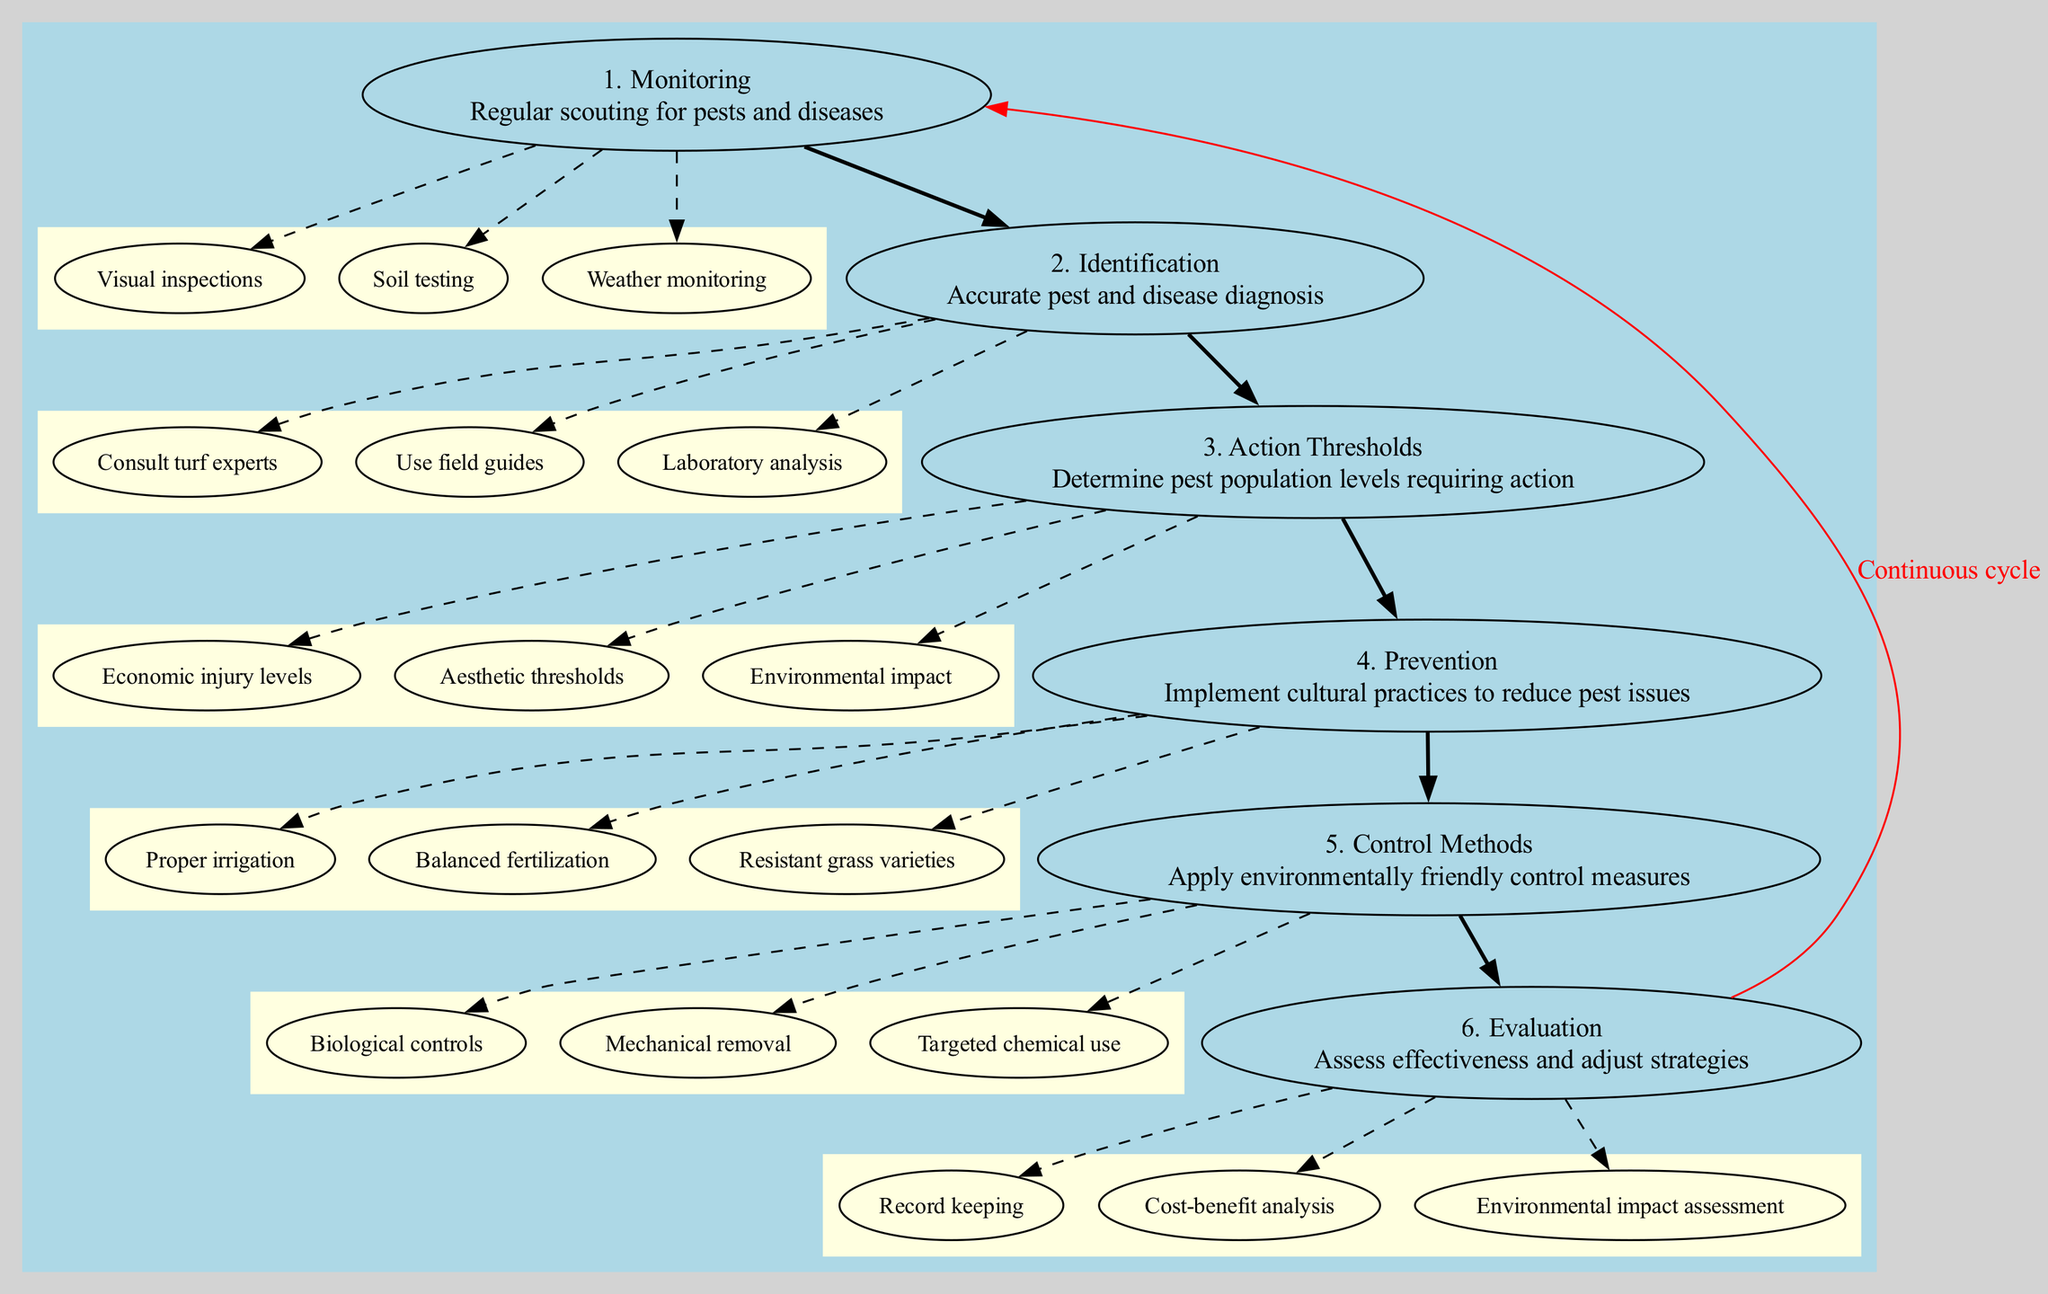What is the first step in the process? The first step in the process is listed as "1. Monitoring" which is clearly indicated in the diagram.
Answer: Monitoring How many main steps are there in the diagram? By counting the nodes representing main steps, we find there are a total of six main steps present in the diagram.
Answer: 6 What is the last step before evaluation? The step just before evaluation is identified as "5. Control Methods" in the flow of the diagram, where the relationship between the steps is defined.
Answer: Control Methods Which method is used for accurate diagnosis in the identification step? The diagram specifically mentions "Consult turf experts" as one of the methods for accurate diagnosis in the identification step, indicating its importance.
Answer: Consult turf experts What connects the evaluation step back to the monitoring step? The connection from evaluation back to monitoring is labeled "Continuous cycle," emphasizing the iterative nature of the process.
Answer: Continuous cycle What is the emphasis of the prevention step? The prevention step emphasizes "Implement cultural practices to reduce pest issues," indicating its focus on proactive strategies.
Answer: Implement cultural practices to reduce pest issues How is the connection between steps indicated in the diagram? Connections between steps are indicated by bold edges, which visually represent the progression from one step to the next.
Answer: Bold edges What is a subitem under the action thresholds step? A subitem listed under the action thresholds step is "Economic injury levels," which highlights a specific criterion for determining action needs.
Answer: Economic injury levels 